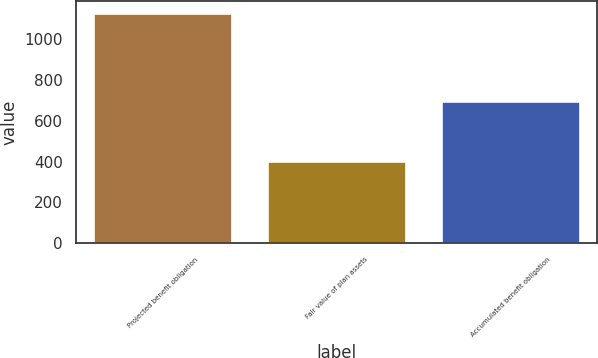Convert chart to OTSL. <chart><loc_0><loc_0><loc_500><loc_500><bar_chart><fcel>Projected benefit obligation<fcel>Fair value of plan assets<fcel>Accumulated benefit obligation<nl><fcel>1130<fcel>402<fcel>700<nl></chart> 